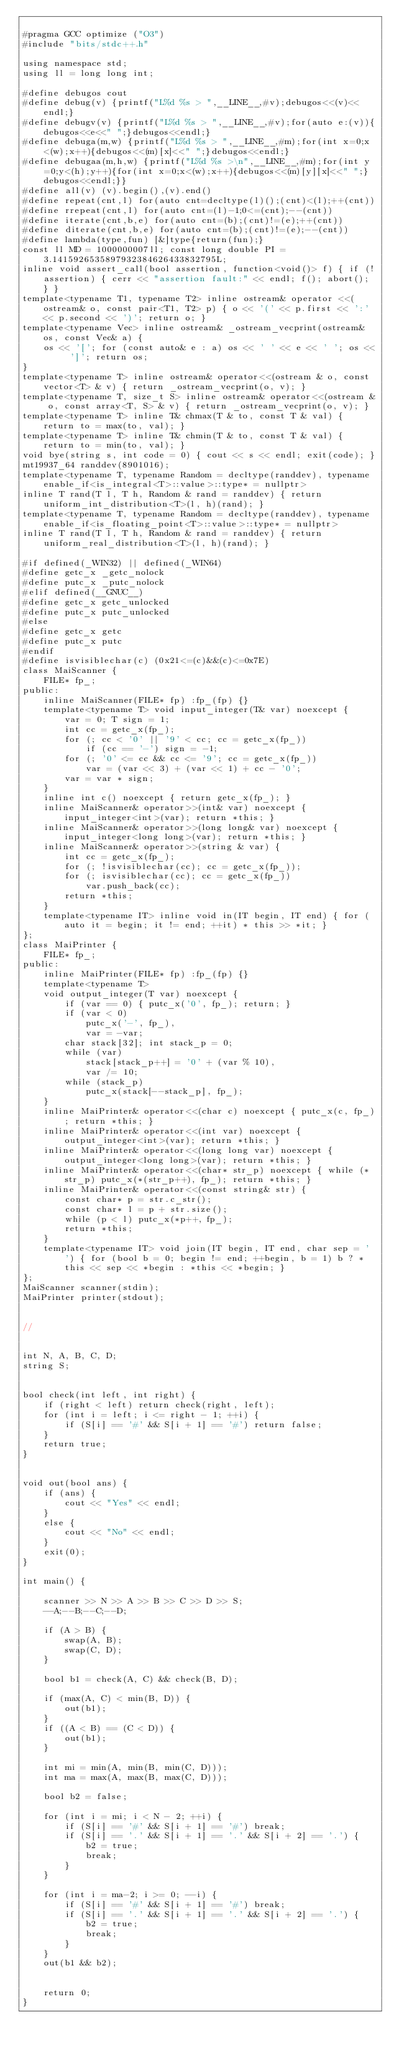<code> <loc_0><loc_0><loc_500><loc_500><_C++_>
#pragma GCC optimize ("O3")
#include "bits/stdc++.h"

using namespace std;
using ll = long long int;

#define debugos cout
#define debug(v) {printf("L%d %s > ",__LINE__,#v);debugos<<(v)<<endl;}
#define debugv(v) {printf("L%d %s > ",__LINE__,#v);for(auto e:(v)){debugos<<e<<" ";}debugos<<endl;}
#define debuga(m,w) {printf("L%d %s > ",__LINE__,#m);for(int x=0;x<(w);x++){debugos<<(m)[x]<<" ";}debugos<<endl;}
#define debugaa(m,h,w) {printf("L%d %s >\n",__LINE__,#m);for(int y=0;y<(h);y++){for(int x=0;x<(w);x++){debugos<<(m)[y][x]<<" ";}debugos<<endl;}}
#define all(v) (v).begin(),(v).end()
#define repeat(cnt,l) for(auto cnt=decltype(l)();(cnt)<(l);++(cnt))
#define rrepeat(cnt,l) for(auto cnt=(l)-1;0<=(cnt);--(cnt))
#define iterate(cnt,b,e) for(auto cnt=(b);(cnt)!=(e);++(cnt))
#define diterate(cnt,b,e) for(auto cnt=(b);(cnt)!=(e);--(cnt))
#define lambda(type,fun) [&]type{return(fun);}
const ll MD = 1000000007ll; const long double PI = 3.1415926535897932384626433832795L;
inline void assert_call(bool assertion, function<void()> f) { if (!assertion) { cerr << "assertion fault:" << endl; f(); abort(); } }
template<typename T1, typename T2> inline ostream& operator <<(ostream& o, const pair<T1, T2> p) { o << '(' << p.first << ':' << p.second << ')'; return o; }
template<typename Vec> inline ostream& _ostream_vecprint(ostream& os, const Vec& a) {
    os << '['; for (const auto& e : a) os << ' ' << e << ' '; os << ']'; return os;
}
template<typename T> inline ostream& operator<<(ostream & o, const vector<T> & v) { return _ostream_vecprint(o, v); }
template<typename T, size_t S> inline ostream& operator<<(ostream & o, const array<T, S> & v) { return _ostream_vecprint(o, v); }
template<typename T> inline T& chmax(T & to, const T & val) { return to = max(to, val); }
template<typename T> inline T& chmin(T & to, const T & val) { return to = min(to, val); }
void bye(string s, int code = 0) { cout << s << endl; exit(code); }
mt19937_64 randdev(8901016);
template<typename T, typename Random = decltype(randdev), typename enable_if<is_integral<T>::value>::type* = nullptr>
inline T rand(T l, T h, Random & rand = randdev) { return uniform_int_distribution<T>(l, h)(rand); }
template<typename T, typename Random = decltype(randdev), typename enable_if<is_floating_point<T>::value>::type* = nullptr>
inline T rand(T l, T h, Random & rand = randdev) { return uniform_real_distribution<T>(l, h)(rand); }

#if defined(_WIN32) || defined(_WIN64)
#define getc_x _getc_nolock
#define putc_x _putc_nolock
#elif defined(__GNUC__)
#define getc_x getc_unlocked
#define putc_x putc_unlocked
#else
#define getc_x getc
#define putc_x putc
#endif
#define isvisiblechar(c) (0x21<=(c)&&(c)<=0x7E)
class MaiScanner {
    FILE* fp_;
public:
    inline MaiScanner(FILE* fp) :fp_(fp) {}
    template<typename T> void input_integer(T& var) noexcept {
        var = 0; T sign = 1;
        int cc = getc_x(fp_);
        for (; cc < '0' || '9' < cc; cc = getc_x(fp_))
            if (cc == '-') sign = -1;
        for (; '0' <= cc && cc <= '9'; cc = getc_x(fp_))
            var = (var << 3) + (var << 1) + cc - '0';
        var = var * sign;
    }
    inline int c() noexcept { return getc_x(fp_); }
    inline MaiScanner& operator>>(int& var) noexcept { input_integer<int>(var); return *this; }
    inline MaiScanner& operator>>(long long& var) noexcept { input_integer<long long>(var); return *this; }
    inline MaiScanner& operator>>(string & var) {
        int cc = getc_x(fp_);
        for (; !isvisiblechar(cc); cc = getc_x(fp_));
        for (; isvisiblechar(cc); cc = getc_x(fp_))
            var.push_back(cc);
        return *this;
    }
    template<typename IT> inline void in(IT begin, IT end) { for (auto it = begin; it != end; ++it) * this >> *it; }
};
class MaiPrinter {
    FILE* fp_;
public:
    inline MaiPrinter(FILE* fp) :fp_(fp) {}
    template<typename T>
    void output_integer(T var) noexcept {
        if (var == 0) { putc_x('0', fp_); return; }
        if (var < 0)
            putc_x('-', fp_),
            var = -var;
        char stack[32]; int stack_p = 0;
        while (var)
            stack[stack_p++] = '0' + (var % 10),
            var /= 10;
        while (stack_p)
            putc_x(stack[--stack_p], fp_);
    }
    inline MaiPrinter& operator<<(char c) noexcept { putc_x(c, fp_); return *this; }
    inline MaiPrinter& operator<<(int var) noexcept { output_integer<int>(var); return *this; }
    inline MaiPrinter& operator<<(long long var) noexcept { output_integer<long long>(var); return *this; }
    inline MaiPrinter& operator<<(char* str_p) noexcept { while (*str_p) putc_x(*(str_p++), fp_); return *this; }
    inline MaiPrinter& operator<<(const string& str) {
        const char* p = str.c_str();
        const char* l = p + str.size();
        while (p < l) putc_x(*p++, fp_);
        return *this;
    }
    template<typename IT> void join(IT begin, IT end, char sep = ' ') { for (bool b = 0; begin != end; ++begin, b = 1) b ? *this << sep << *begin : *this << *begin; }
};
MaiScanner scanner(stdin);
MaiPrinter printer(stdout);


//


int N, A, B, C, D;
string S;


bool check(int left, int right) {
    if (right < left) return check(right, left);
    for (int i = left; i <= right - 1; ++i) {
        if (S[i] == '#' && S[i + 1] == '#') return false;
    }
    return true;
}


void out(bool ans) {
    if (ans) {
        cout << "Yes" << endl;
    }
    else {
        cout << "No" << endl;
    }
    exit(0);
}

int main() {

    scanner >> N >> A >> B >> C >> D >> S;
    --A;--B;--C;--D;

    if (A > B) {
        swap(A, B);
        swap(C, D);
    }

    bool b1 = check(A, C) && check(B, D);

    if (max(A, C) < min(B, D)) {
        out(b1);
    }
    if ((A < B) == (C < D)) {
        out(b1);
    }

    int mi = min(A, min(B, min(C, D)));
    int ma = max(A, max(B, max(C, D)));

    bool b2 = false;

    for (int i = mi; i < N - 2; ++i) {
        if (S[i] == '#' && S[i + 1] == '#') break;
        if (S[i] == '.' && S[i + 1] == '.' && S[i + 2] == '.') {
            b2 = true;
            break;
        }
    }

    for (int i = ma-2; i >= 0; --i) {
        if (S[i] == '#' && S[i + 1] == '#') break;
        if (S[i] == '.' && S[i + 1] == '.' && S[i + 2] == '.') {
            b2 = true;
            break;
        }
    }
    out(b1 && b2);


    return 0;
}</code> 